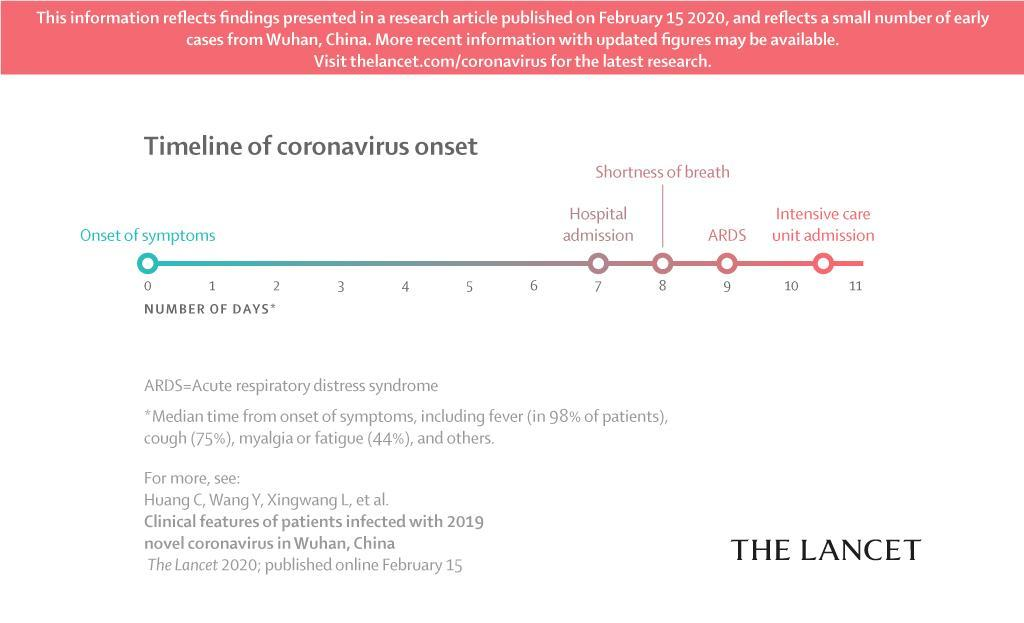What percentage of corona patients are not getting fever as its symptoms?
Answer the question with a short phrase. 2 What is the first symptom observed in patient after admitting in Hospital? Shortness of breadth What is the symptom observed in corona patient on day 9? ARDS On which day the corona virus infected patient was admitted in the hospital? 7 What percentage of corona patients are not getting fatigue as its symptoms? 56 What percentage of corona patients are not getting cough as its symptoms? 25 